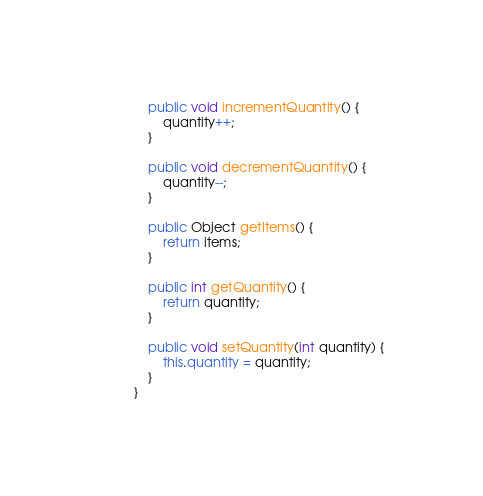Convert code to text. <code><loc_0><loc_0><loc_500><loc_500><_Java_>
	public void incrementQuantity() {
		quantity++;
	}

	public void decrementQuantity() {
		quantity--;
	}

	public Object getItems() {
		return items;
	}

	public int getQuantity() {
		return quantity;
	}

	public void setQuantity(int quantity) {
		this.quantity = quantity;
	}
}
</code> 